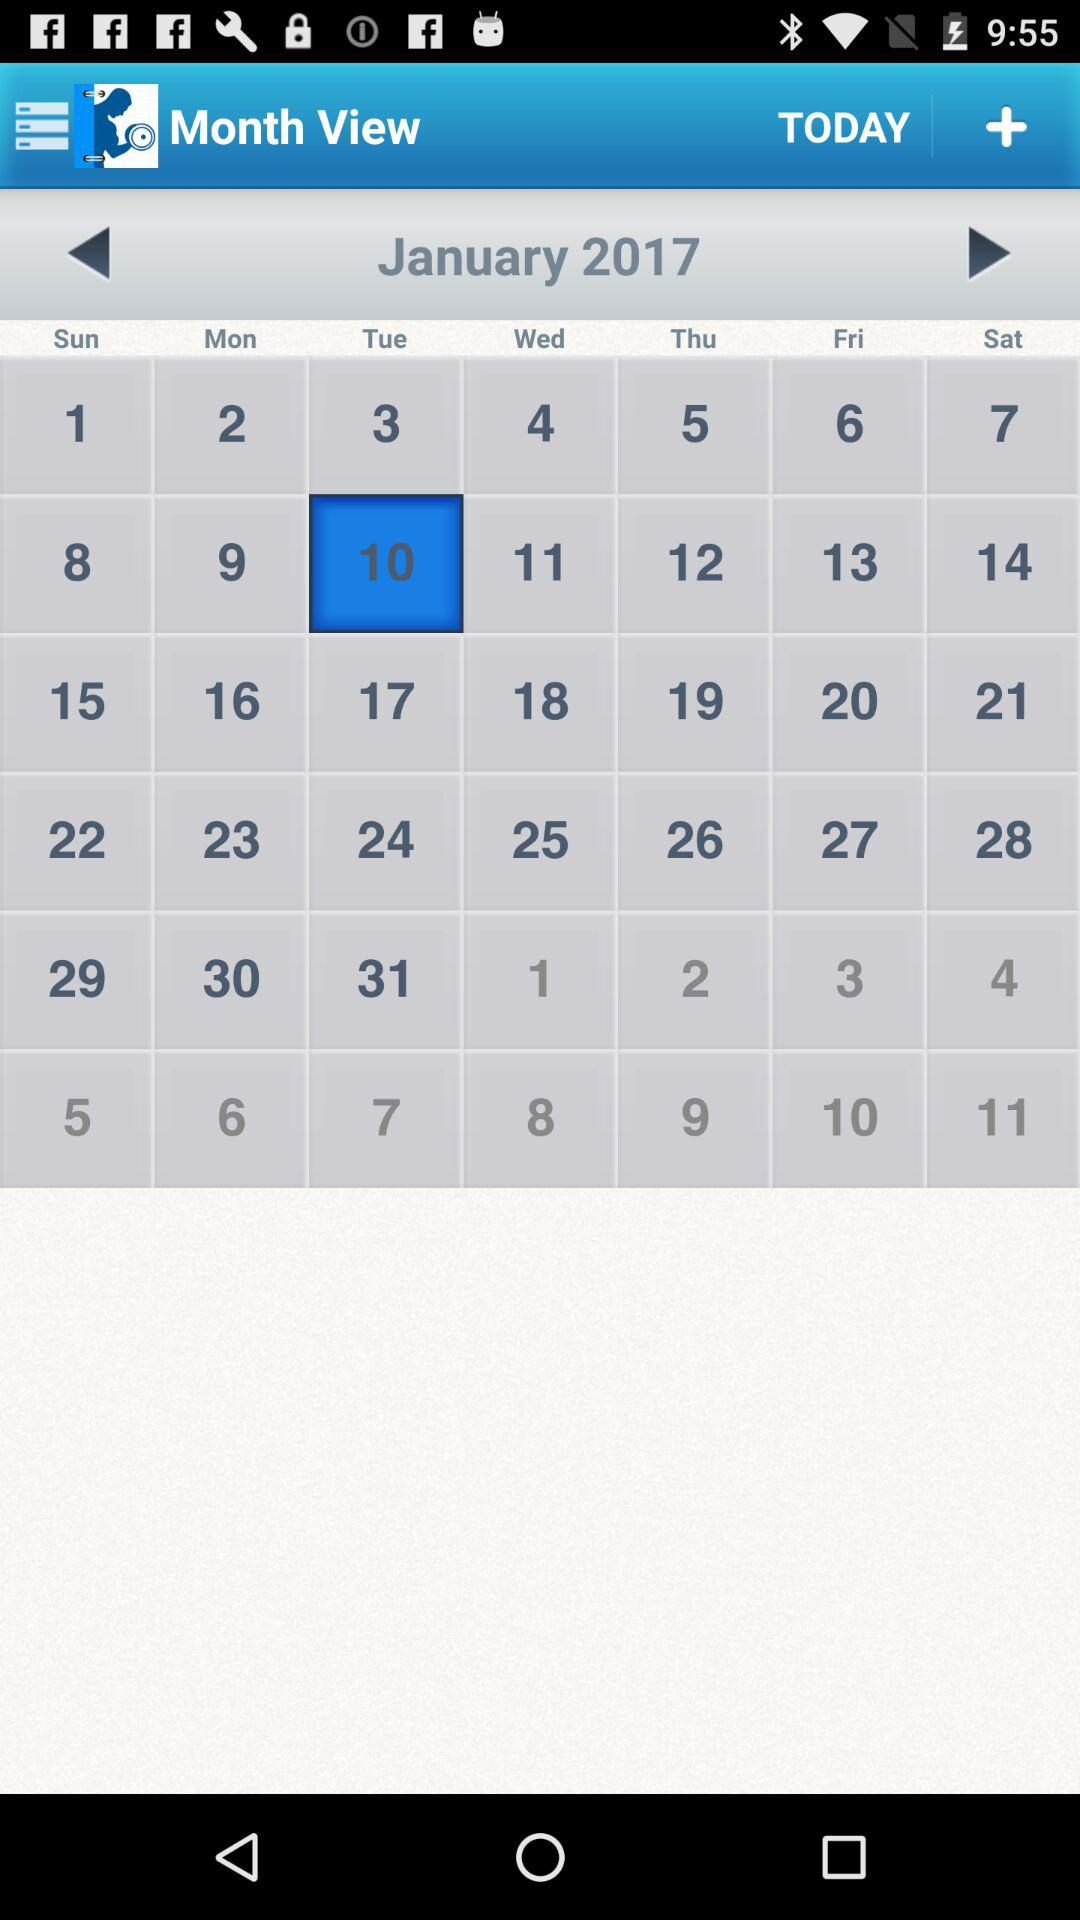What is the selected date? The selected date is Tuesday, January 10, 2017. 